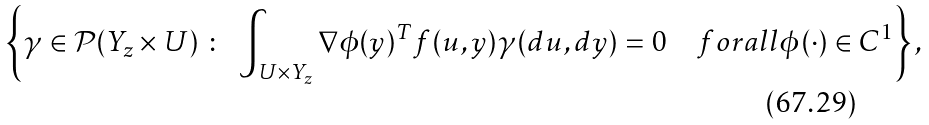Convert formula to latex. <formula><loc_0><loc_0><loc_500><loc_500>\left \{ \gamma \in \mathcal { P } ( Y _ { z } \times U ) \ \colon \ \int _ { U \times Y _ { z } } \nabla \phi ( y ) ^ { T } f ( u , y ) \gamma ( d u , d y ) = 0 \quad f o r a l l \phi ( \cdot ) \in C ^ { 1 } \right \} ,</formula> 